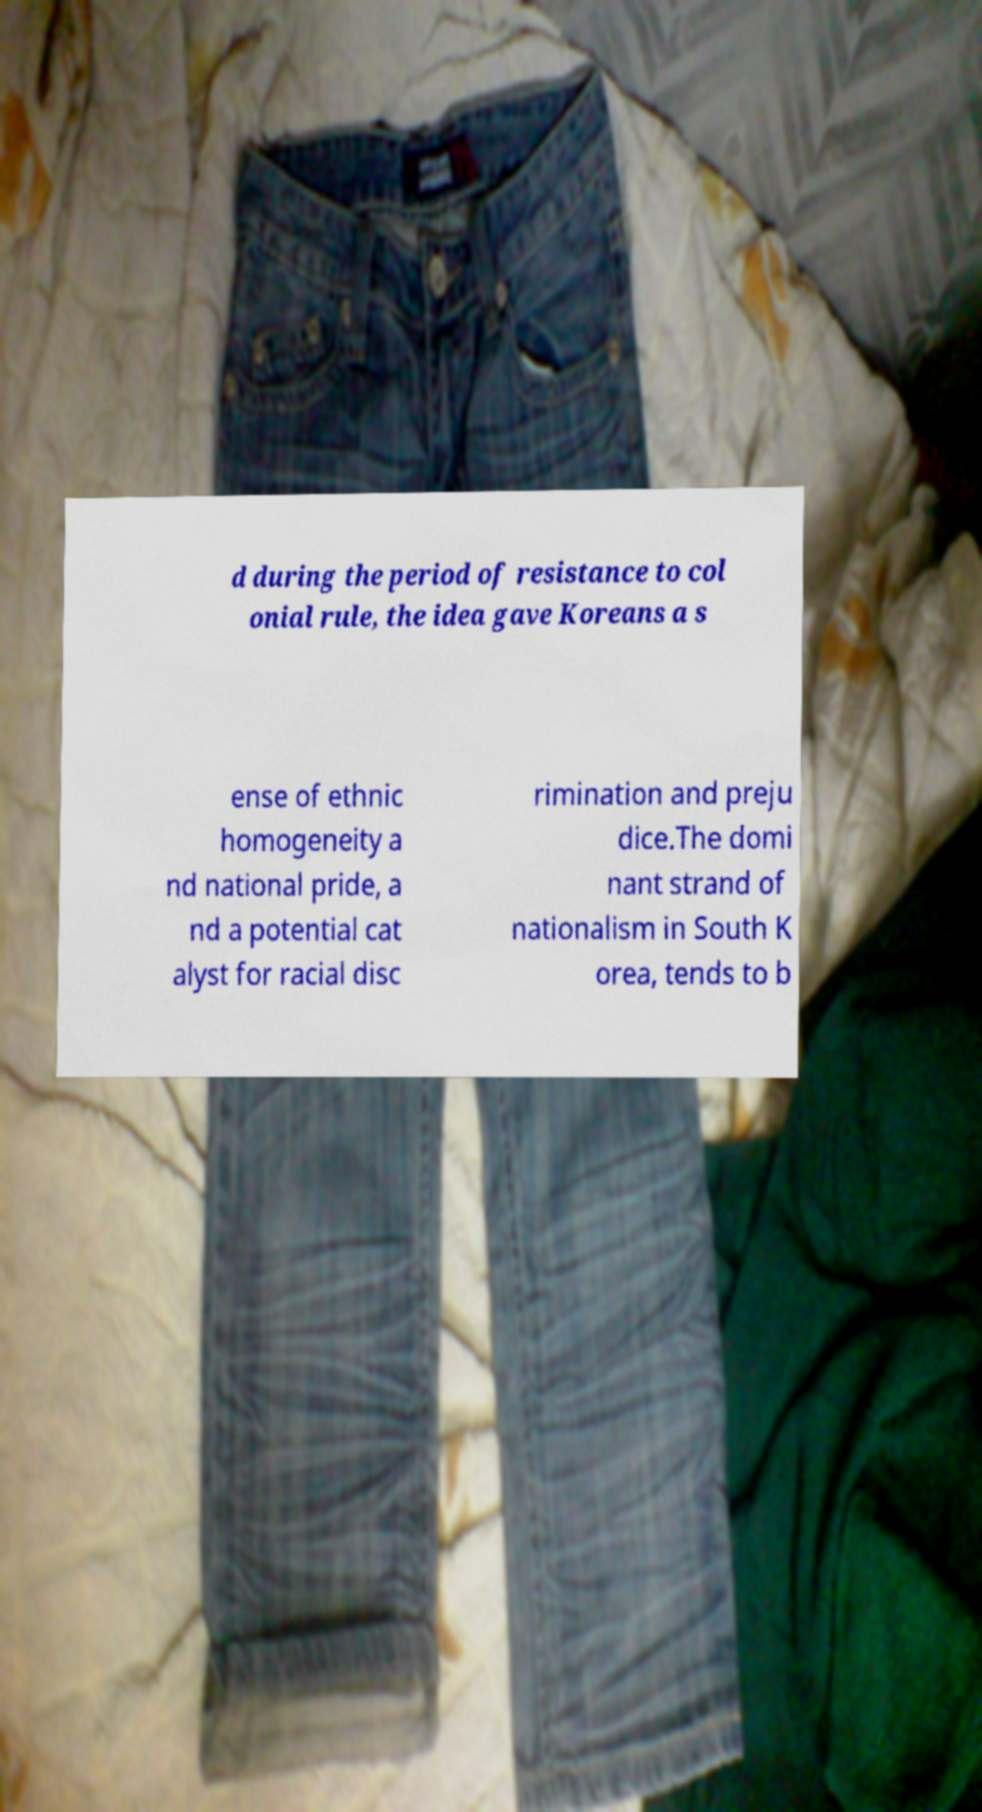Can you accurately transcribe the text from the provided image for me? d during the period of resistance to col onial rule, the idea gave Koreans a s ense of ethnic homogeneity a nd national pride, a nd a potential cat alyst for racial disc rimination and preju dice.The domi nant strand of nationalism in South K orea, tends to b 